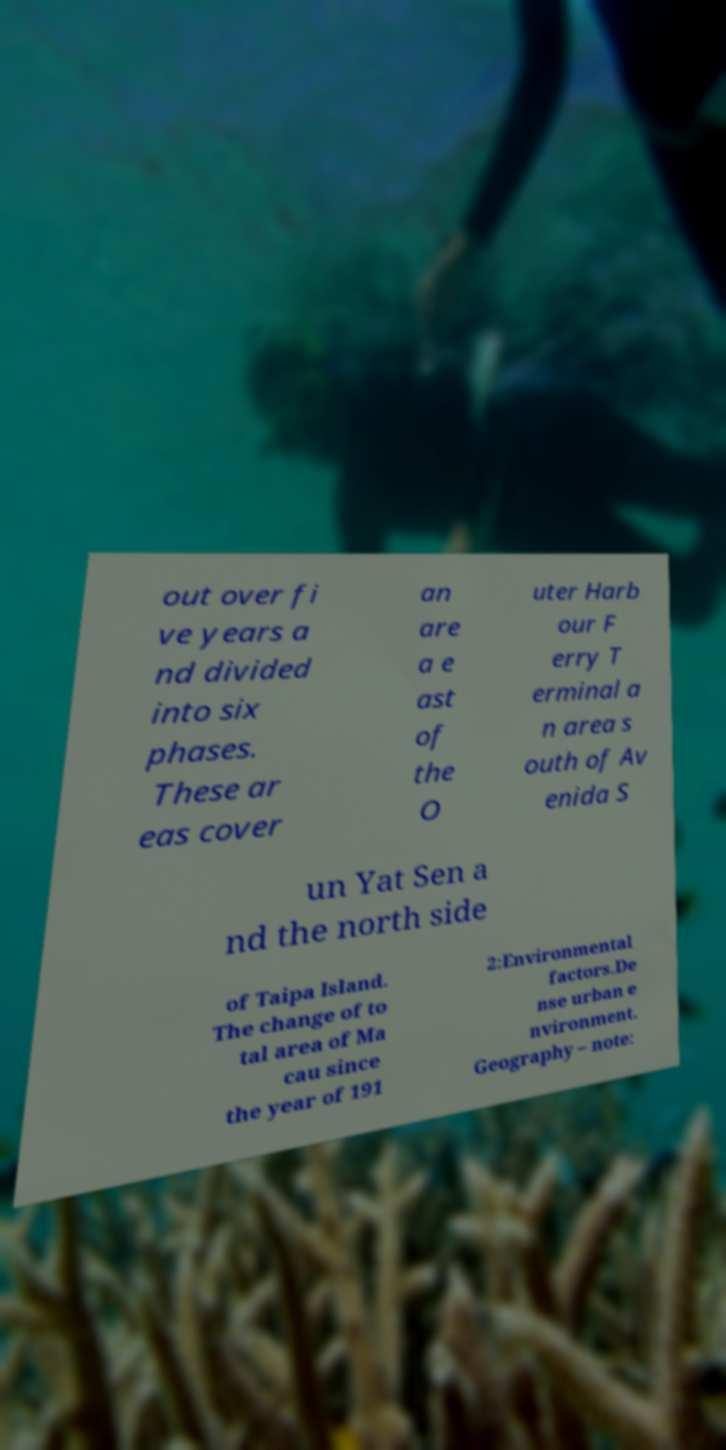I need the written content from this picture converted into text. Can you do that? out over fi ve years a nd divided into six phases. These ar eas cover an are a e ast of the O uter Harb our F erry T erminal a n area s outh of Av enida S un Yat Sen a nd the north side of Taipa Island. The change of to tal area of Ma cau since the year of 191 2:Environmental factors.De nse urban e nvironment. Geography – note: 